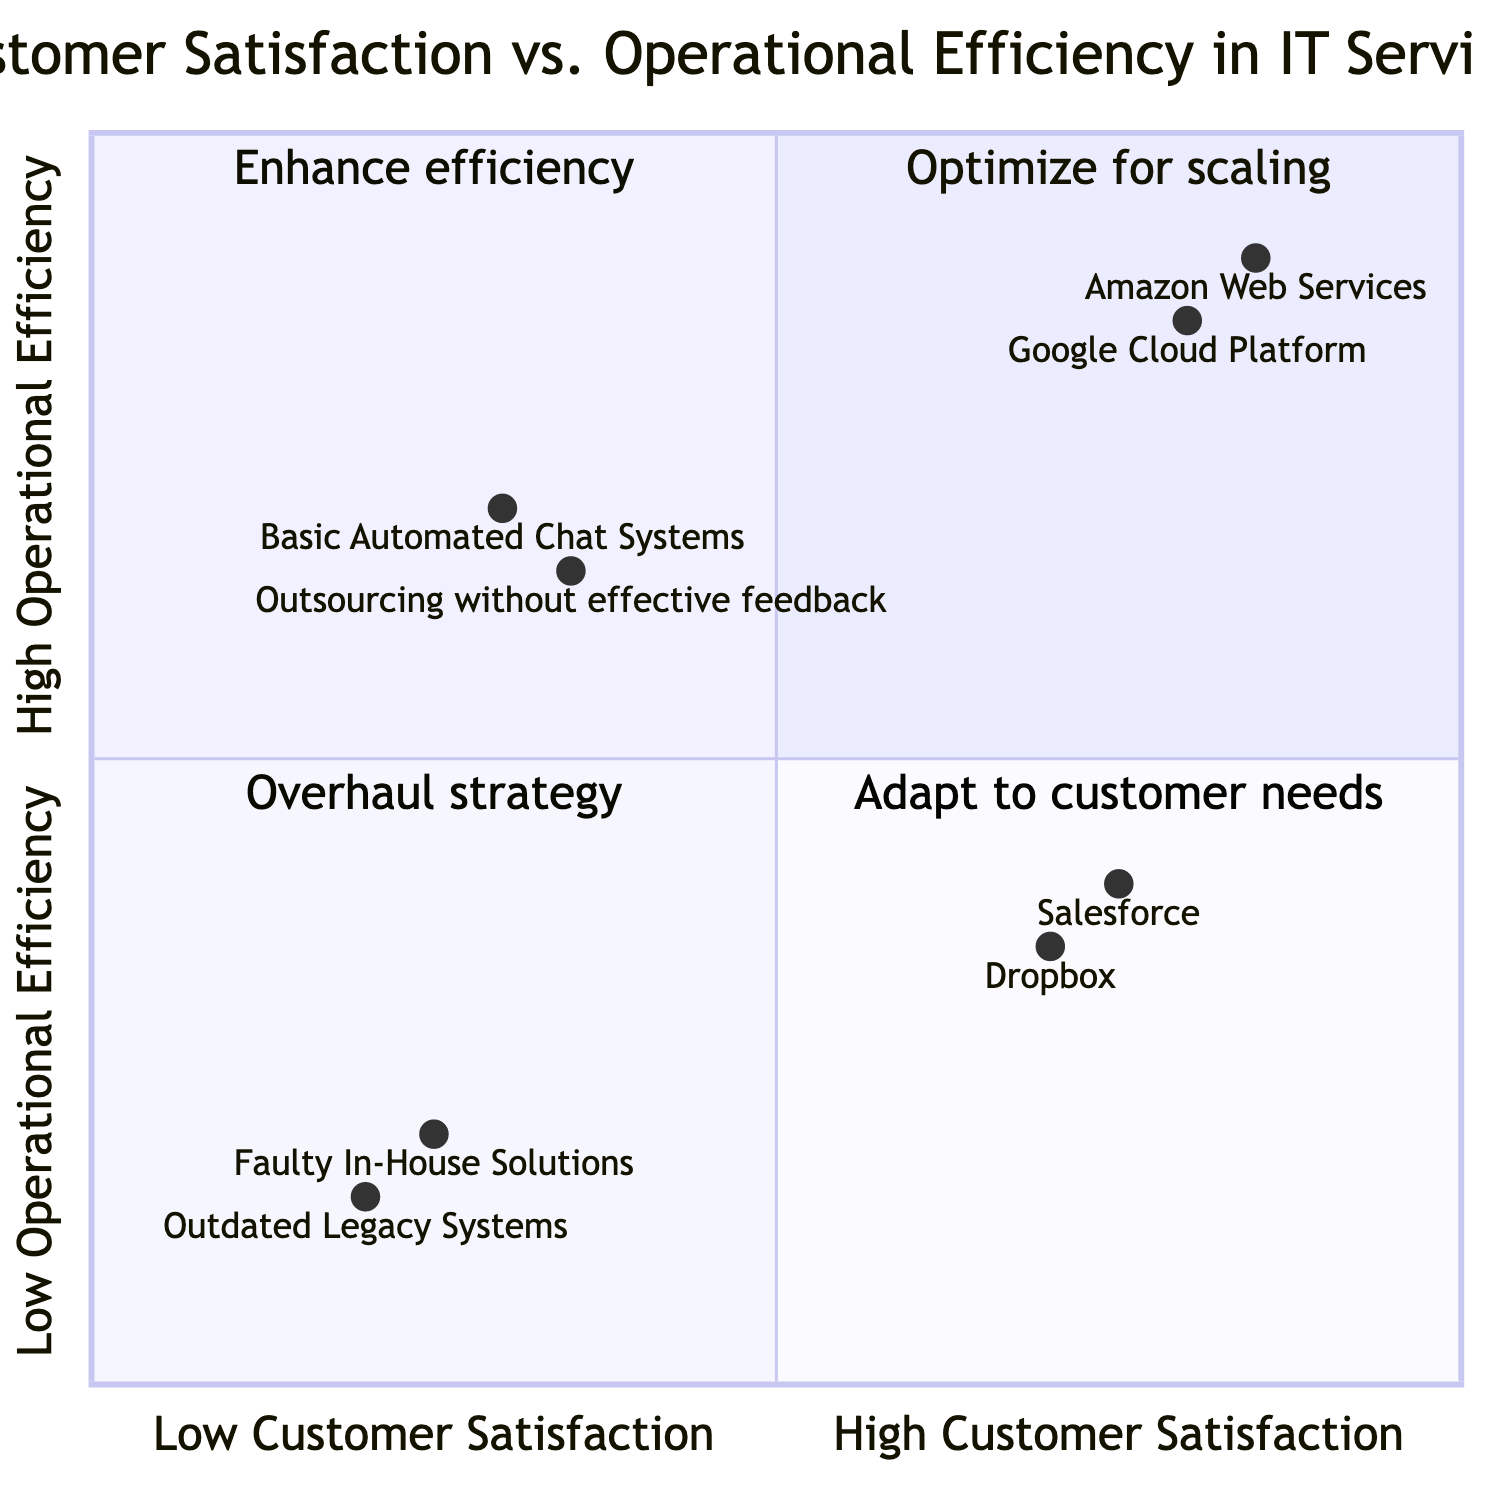What is the highest Customer Satisfaction score in the chart? The highest Customer Satisfaction score is associated with Amazon Web Services, which has a value of 0.85 on the x-axis. Thus, when checking the values, the highest is found at this service.
Answer: 0.85 How many services are located in the High Satisfaction, High Efficiency quadrant? The High Satisfaction, High Efficiency quadrant contains two services: Amazon Web Services and Google Cloud Platform. By counting these, we conclude that the number is two.
Answer: 2 In which quadrant is Salesforce plotted? Salesforce is listed with coordinates [0.75, 0.40], which places it in the High Satisfaction, Low Efficiency quadrant due to its x-value being greater than 0.5 and y-value less than 0.5.
Answer: High Satisfaction, Low Efficiency What is the description of the Low Satisfaction, High Efficiency quadrant? The description for the Low Satisfaction, High Efficiency quadrant is to monitor and adapt offerings to better meet customer needs. This description conveys the strategic focus needed in this situation.
Answer: Monitor and adapt offerings Which service has the lowest Operational Efficiency score? The service with the lowest Operational Efficiency score is Faulty In-House Solutions, which is represented with a score of 0.20 on the y-axis. Therefore, it indicates the least efficiency in the entire chart.
Answer: Faulty In-House Solutions What strategies should be implemented for services in the Low Satisfaction, Low Efficiency quadrant? Services in the Low Satisfaction, Low Efficiency quadrant require a complete overhaul in strategy and operations to improve both customer satisfaction and operational efficiency significantly. This strategic requirement directs the approach needed.
Answer: Complete overhaul in strategy How many services fall into the Low Satisfaction quadrant? In this case, there are four services that fall into either the Low Satisfaction, Low Efficiency or Low Satisfaction, High Efficiency quadrants combined. Therefore, we simply count them from their representations.
Answer: 4 Which service has the highest Operational Efficiency score? The highest Operational Efficiency score is associated with Google Cloud Platform at 0.85, making it the most efficient service in the chart when examining the coordinates.
Answer: Google Cloud Platform 